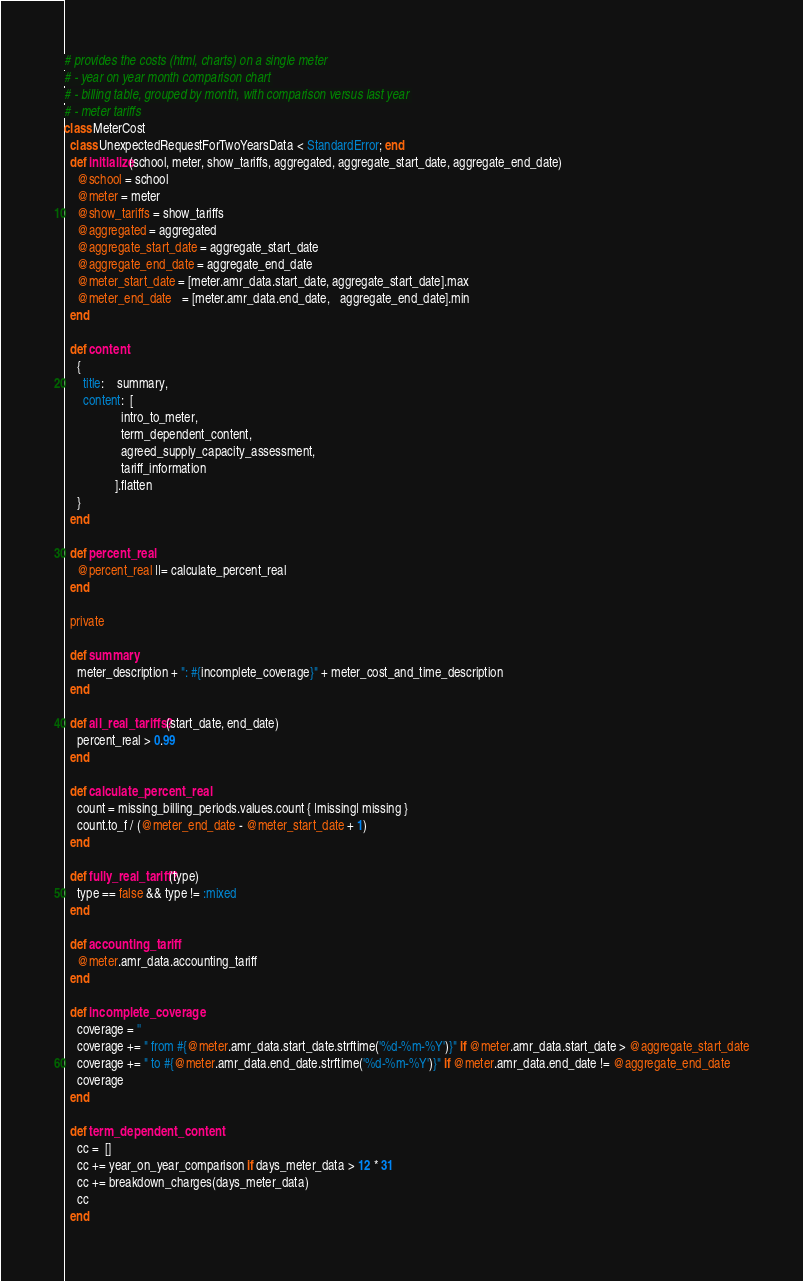Convert code to text. <code><loc_0><loc_0><loc_500><loc_500><_Ruby_># provides the costs (html, charts) on a single meter
# - year on year month comparison chart
# - billing table, grouped by month, with comparison versus last year
# - meter tariffs
class MeterCost
  class UnexpectedRequestForTwoYearsData < StandardError; end
  def initialize(school, meter, show_tariffs, aggregated, aggregate_start_date, aggregate_end_date)
    @school = school
    @meter = meter
    @show_tariffs = show_tariffs
    @aggregated = aggregated
    @aggregate_start_date = aggregate_start_date
    @aggregate_end_date = aggregate_end_date
    @meter_start_date = [meter.amr_data.start_date, aggregate_start_date].max
    @meter_end_date   = [meter.amr_data.end_date,   aggregate_end_date].min
  end

  def content
    {
      title:    summary,
      content:  [
                  intro_to_meter,
                  term_dependent_content,
                  agreed_supply_capacity_assessment,
                  tariff_information
                ].flatten
    }
  end

  def percent_real
    @percent_real ||= calculate_percent_real
  end

  private

  def summary
    meter_description + ": #{incomplete_coverage}" + meter_cost_and_time_description
  end

  def all_real_tariffs?(start_date, end_date)
    percent_real > 0.99
  end

  def calculate_percent_real
    count = missing_billing_periods.values.count { |missing| missing }
    count.to_f / (@meter_end_date - @meter_start_date + 1)
  end

  def fully_real_tariff?(type)
    type == false && type != :mixed
  end

  def accounting_tariff
    @meter.amr_data.accounting_tariff
  end

  def incomplete_coverage
    coverage = ''
    coverage += " from #{@meter.amr_data.start_date.strftime('%d-%m-%Y')}" if @meter.amr_data.start_date > @aggregate_start_date
    coverage += " to #{@meter.amr_data.end_date.strftime('%d-%m-%Y')}" if @meter.amr_data.end_date != @aggregate_end_date
    coverage
  end

  def term_dependent_content
    cc =  []
    cc += year_on_year_comparison if days_meter_data > 12 * 31
    cc += breakdown_charges(days_meter_data)
    cc
  end
</code> 